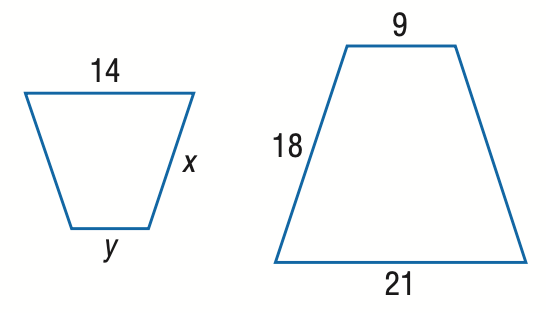Answer the mathemtical geometry problem and directly provide the correct option letter.
Question: Find x.
Choices: A: 9 B: 12 C: 15 D: 16 B 